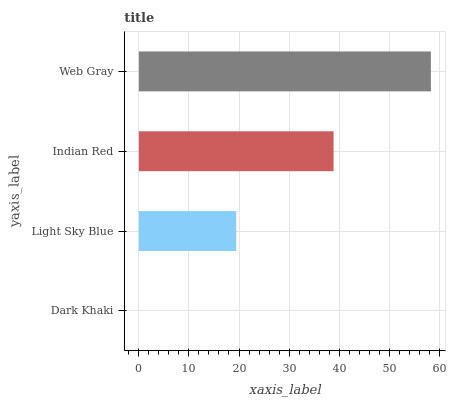Is Dark Khaki the minimum?
Answer yes or no. Yes. Is Web Gray the maximum?
Answer yes or no. Yes. Is Light Sky Blue the minimum?
Answer yes or no. No. Is Light Sky Blue the maximum?
Answer yes or no. No. Is Light Sky Blue greater than Dark Khaki?
Answer yes or no. Yes. Is Dark Khaki less than Light Sky Blue?
Answer yes or no. Yes. Is Dark Khaki greater than Light Sky Blue?
Answer yes or no. No. Is Light Sky Blue less than Dark Khaki?
Answer yes or no. No. Is Indian Red the high median?
Answer yes or no. Yes. Is Light Sky Blue the low median?
Answer yes or no. Yes. Is Dark Khaki the high median?
Answer yes or no. No. Is Web Gray the low median?
Answer yes or no. No. 